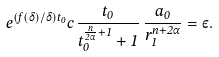Convert formula to latex. <formula><loc_0><loc_0><loc_500><loc_500>e ^ { ( f ( \delta ) / \delta ) t _ { 0 } } c \, \frac { t _ { 0 } } { t _ { 0 } ^ { \frac { n } { 2 \alpha } + 1 } + 1 } \, \frac { a _ { 0 } } { r _ { 1 } ^ { n + 2 \alpha } } = \varepsilon .</formula> 